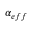Convert formula to latex. <formula><loc_0><loc_0><loc_500><loc_500>\alpha _ { e f f }</formula> 